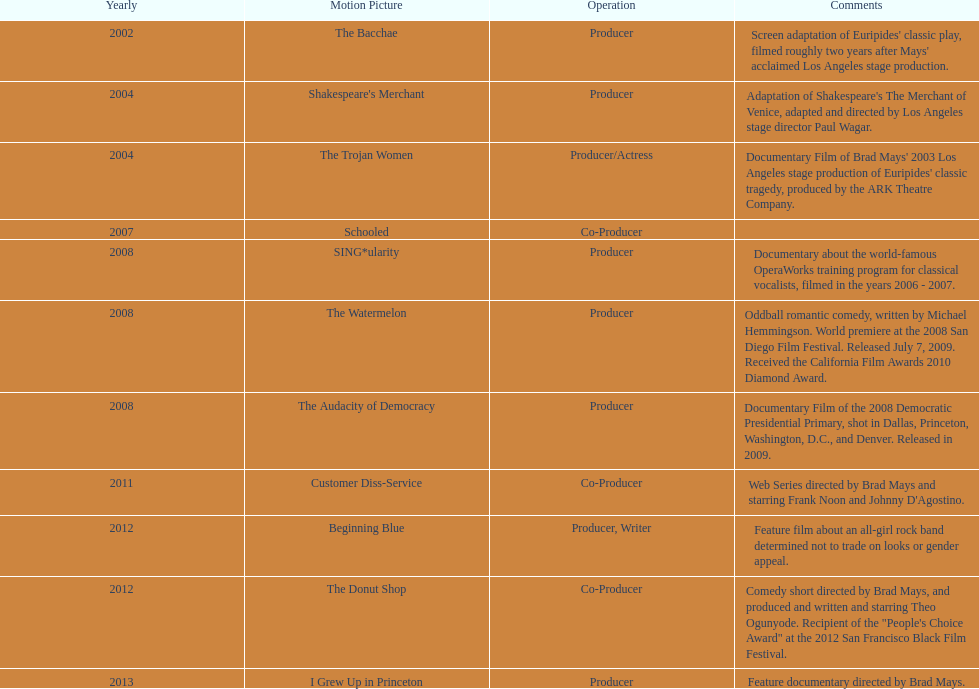How many films did ms. starfelt produce after 2010? 4. 